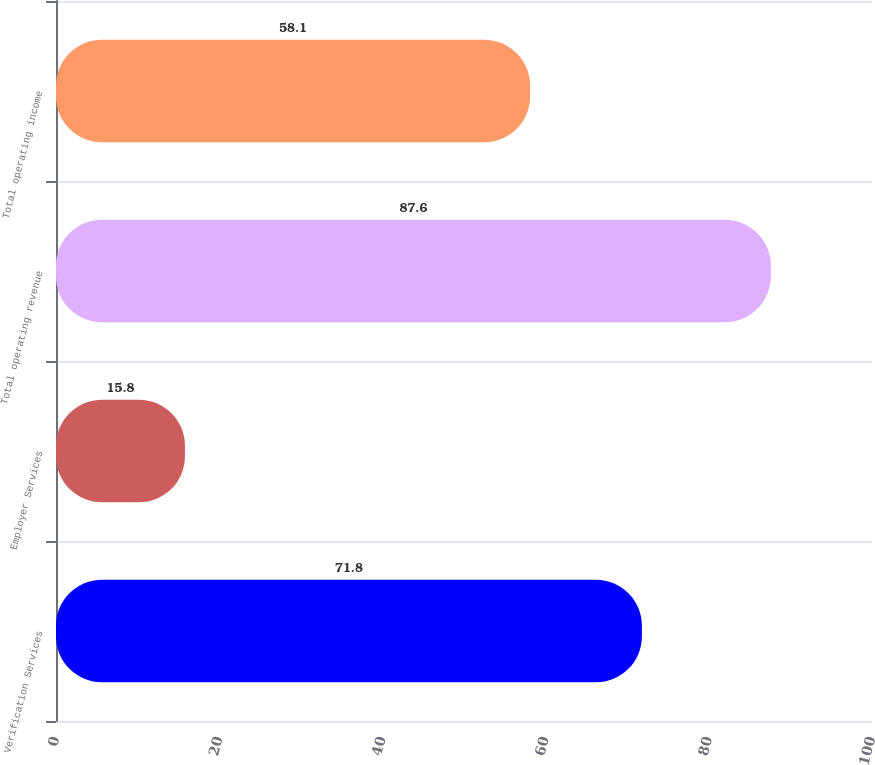<chart> <loc_0><loc_0><loc_500><loc_500><bar_chart><fcel>Verification Services<fcel>Employer Services<fcel>Total operating revenue<fcel>Total operating income<nl><fcel>71.8<fcel>15.8<fcel>87.6<fcel>58.1<nl></chart> 